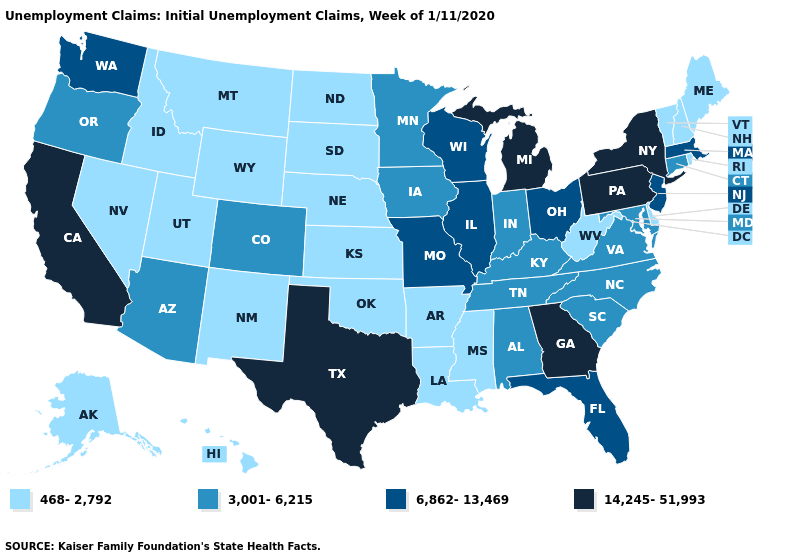What is the value of Virginia?
Write a very short answer. 3,001-6,215. What is the value of Nevada?
Quick response, please. 468-2,792. What is the highest value in the Northeast ?
Short answer required. 14,245-51,993. Does Louisiana have the lowest value in the USA?
Concise answer only. Yes. Name the states that have a value in the range 14,245-51,993?
Answer briefly. California, Georgia, Michigan, New York, Pennsylvania, Texas. What is the lowest value in the MidWest?
Answer briefly. 468-2,792. What is the lowest value in the USA?
Quick response, please. 468-2,792. Does Hawaii have the highest value in the West?
Answer briefly. No. What is the value of Nevada?
Answer briefly. 468-2,792. Does South Carolina have a lower value than California?
Answer briefly. Yes. Which states hav the highest value in the MidWest?
Answer briefly. Michigan. What is the lowest value in the USA?
Be succinct. 468-2,792. Is the legend a continuous bar?
Give a very brief answer. No. Which states have the highest value in the USA?
Short answer required. California, Georgia, Michigan, New York, Pennsylvania, Texas. What is the value of Indiana?
Be succinct. 3,001-6,215. 